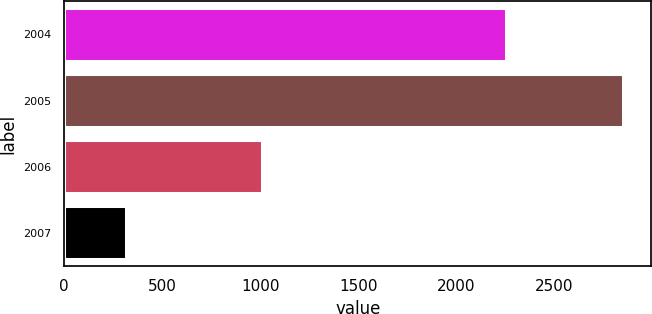<chart> <loc_0><loc_0><loc_500><loc_500><bar_chart><fcel>2004<fcel>2005<fcel>2006<fcel>2007<nl><fcel>2255<fcel>2853<fcel>1009<fcel>314<nl></chart> 